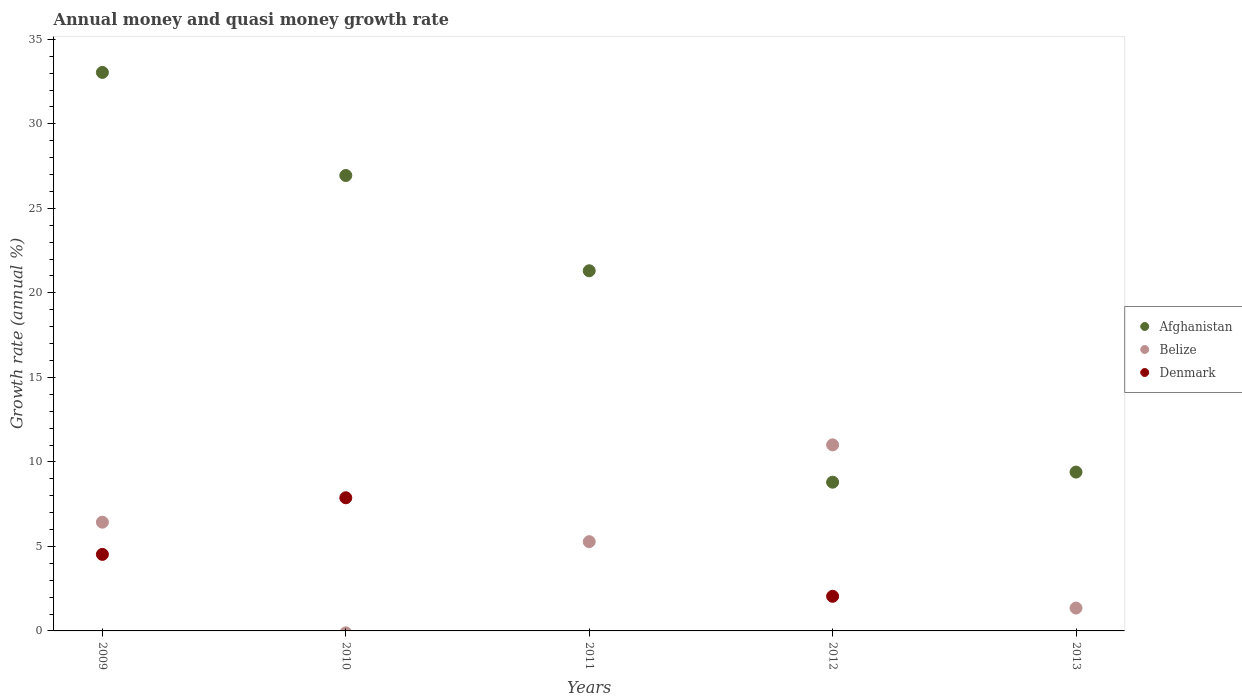What is the growth rate in Denmark in 2012?
Give a very brief answer. 2.05. Across all years, what is the maximum growth rate in Denmark?
Provide a succinct answer. 7.88. Across all years, what is the minimum growth rate in Afghanistan?
Your answer should be very brief. 8.8. What is the total growth rate in Denmark in the graph?
Provide a short and direct response. 14.46. What is the difference between the growth rate in Belize in 2012 and that in 2013?
Your response must be concise. 9.66. What is the difference between the growth rate in Denmark in 2009 and the growth rate in Afghanistan in 2010?
Your answer should be very brief. -22.42. What is the average growth rate in Belize per year?
Give a very brief answer. 4.82. In the year 2009, what is the difference between the growth rate in Belize and growth rate in Denmark?
Your response must be concise. 1.91. What is the ratio of the growth rate in Afghanistan in 2010 to that in 2011?
Offer a very short reply. 1.26. Is the growth rate in Denmark in 2009 less than that in 2012?
Give a very brief answer. No. What is the difference between the highest and the second highest growth rate in Afghanistan?
Your answer should be very brief. 6.1. What is the difference between the highest and the lowest growth rate in Afghanistan?
Provide a short and direct response. 24.24. In how many years, is the growth rate in Denmark greater than the average growth rate in Denmark taken over all years?
Keep it short and to the point. 2. Is the growth rate in Belize strictly greater than the growth rate in Afghanistan over the years?
Make the answer very short. No. How many dotlines are there?
Your answer should be compact. 3. How many years are there in the graph?
Keep it short and to the point. 5. What is the difference between two consecutive major ticks on the Y-axis?
Your answer should be compact. 5. Are the values on the major ticks of Y-axis written in scientific E-notation?
Offer a very short reply. No. Where does the legend appear in the graph?
Your answer should be compact. Center right. How many legend labels are there?
Provide a succinct answer. 3. How are the legend labels stacked?
Ensure brevity in your answer.  Vertical. What is the title of the graph?
Offer a terse response. Annual money and quasi money growth rate. Does "Hong Kong" appear as one of the legend labels in the graph?
Make the answer very short. No. What is the label or title of the X-axis?
Your answer should be compact. Years. What is the label or title of the Y-axis?
Ensure brevity in your answer.  Growth rate (annual %). What is the Growth rate (annual %) in Afghanistan in 2009?
Make the answer very short. 33.05. What is the Growth rate (annual %) in Belize in 2009?
Your answer should be very brief. 6.43. What is the Growth rate (annual %) of Denmark in 2009?
Your response must be concise. 4.53. What is the Growth rate (annual %) of Afghanistan in 2010?
Offer a very short reply. 26.95. What is the Growth rate (annual %) of Belize in 2010?
Offer a terse response. 0. What is the Growth rate (annual %) of Denmark in 2010?
Provide a succinct answer. 7.88. What is the Growth rate (annual %) in Afghanistan in 2011?
Offer a very short reply. 21.31. What is the Growth rate (annual %) of Belize in 2011?
Provide a short and direct response. 5.28. What is the Growth rate (annual %) of Denmark in 2011?
Your response must be concise. 0. What is the Growth rate (annual %) of Afghanistan in 2012?
Your answer should be very brief. 8.8. What is the Growth rate (annual %) of Belize in 2012?
Your answer should be compact. 11.01. What is the Growth rate (annual %) in Denmark in 2012?
Provide a short and direct response. 2.05. What is the Growth rate (annual %) of Afghanistan in 2013?
Offer a very short reply. 9.4. What is the Growth rate (annual %) in Belize in 2013?
Make the answer very short. 1.35. Across all years, what is the maximum Growth rate (annual %) in Afghanistan?
Your answer should be compact. 33.05. Across all years, what is the maximum Growth rate (annual %) in Belize?
Offer a very short reply. 11.01. Across all years, what is the maximum Growth rate (annual %) of Denmark?
Ensure brevity in your answer.  7.88. Across all years, what is the minimum Growth rate (annual %) in Afghanistan?
Ensure brevity in your answer.  8.8. Across all years, what is the minimum Growth rate (annual %) in Denmark?
Offer a terse response. 0. What is the total Growth rate (annual %) of Afghanistan in the graph?
Offer a very short reply. 99.5. What is the total Growth rate (annual %) in Belize in the graph?
Provide a short and direct response. 24.08. What is the total Growth rate (annual %) of Denmark in the graph?
Your answer should be compact. 14.46. What is the difference between the Growth rate (annual %) of Afghanistan in 2009 and that in 2010?
Offer a terse response. 6.1. What is the difference between the Growth rate (annual %) of Denmark in 2009 and that in 2010?
Ensure brevity in your answer.  -3.35. What is the difference between the Growth rate (annual %) in Afghanistan in 2009 and that in 2011?
Your answer should be compact. 11.74. What is the difference between the Growth rate (annual %) in Belize in 2009 and that in 2011?
Your answer should be very brief. 1.15. What is the difference between the Growth rate (annual %) of Afghanistan in 2009 and that in 2012?
Your answer should be compact. 24.25. What is the difference between the Growth rate (annual %) of Belize in 2009 and that in 2012?
Your answer should be very brief. -4.57. What is the difference between the Growth rate (annual %) in Denmark in 2009 and that in 2012?
Give a very brief answer. 2.48. What is the difference between the Growth rate (annual %) of Afghanistan in 2009 and that in 2013?
Keep it short and to the point. 23.65. What is the difference between the Growth rate (annual %) in Belize in 2009 and that in 2013?
Your response must be concise. 5.08. What is the difference between the Growth rate (annual %) in Afghanistan in 2010 and that in 2011?
Offer a very short reply. 5.64. What is the difference between the Growth rate (annual %) in Afghanistan in 2010 and that in 2012?
Keep it short and to the point. 18.15. What is the difference between the Growth rate (annual %) of Denmark in 2010 and that in 2012?
Provide a succinct answer. 5.83. What is the difference between the Growth rate (annual %) of Afghanistan in 2010 and that in 2013?
Offer a terse response. 17.55. What is the difference between the Growth rate (annual %) in Afghanistan in 2011 and that in 2012?
Give a very brief answer. 12.51. What is the difference between the Growth rate (annual %) in Belize in 2011 and that in 2012?
Your response must be concise. -5.73. What is the difference between the Growth rate (annual %) in Afghanistan in 2011 and that in 2013?
Give a very brief answer. 11.91. What is the difference between the Growth rate (annual %) of Belize in 2011 and that in 2013?
Ensure brevity in your answer.  3.93. What is the difference between the Growth rate (annual %) of Afghanistan in 2012 and that in 2013?
Your answer should be very brief. -0.6. What is the difference between the Growth rate (annual %) of Belize in 2012 and that in 2013?
Your answer should be very brief. 9.66. What is the difference between the Growth rate (annual %) in Afghanistan in 2009 and the Growth rate (annual %) in Denmark in 2010?
Your response must be concise. 25.17. What is the difference between the Growth rate (annual %) in Belize in 2009 and the Growth rate (annual %) in Denmark in 2010?
Offer a very short reply. -1.44. What is the difference between the Growth rate (annual %) in Afghanistan in 2009 and the Growth rate (annual %) in Belize in 2011?
Give a very brief answer. 27.76. What is the difference between the Growth rate (annual %) in Afghanistan in 2009 and the Growth rate (annual %) in Belize in 2012?
Provide a succinct answer. 22.04. What is the difference between the Growth rate (annual %) in Afghanistan in 2009 and the Growth rate (annual %) in Denmark in 2012?
Your answer should be very brief. 31. What is the difference between the Growth rate (annual %) of Belize in 2009 and the Growth rate (annual %) of Denmark in 2012?
Your response must be concise. 4.39. What is the difference between the Growth rate (annual %) in Afghanistan in 2009 and the Growth rate (annual %) in Belize in 2013?
Keep it short and to the point. 31.69. What is the difference between the Growth rate (annual %) in Afghanistan in 2010 and the Growth rate (annual %) in Belize in 2011?
Your response must be concise. 21.67. What is the difference between the Growth rate (annual %) of Afghanistan in 2010 and the Growth rate (annual %) of Belize in 2012?
Provide a short and direct response. 15.94. What is the difference between the Growth rate (annual %) in Afghanistan in 2010 and the Growth rate (annual %) in Denmark in 2012?
Your answer should be very brief. 24.9. What is the difference between the Growth rate (annual %) of Afghanistan in 2010 and the Growth rate (annual %) of Belize in 2013?
Make the answer very short. 25.59. What is the difference between the Growth rate (annual %) of Afghanistan in 2011 and the Growth rate (annual %) of Belize in 2012?
Give a very brief answer. 10.3. What is the difference between the Growth rate (annual %) in Afghanistan in 2011 and the Growth rate (annual %) in Denmark in 2012?
Ensure brevity in your answer.  19.26. What is the difference between the Growth rate (annual %) in Belize in 2011 and the Growth rate (annual %) in Denmark in 2012?
Offer a very short reply. 3.23. What is the difference between the Growth rate (annual %) in Afghanistan in 2011 and the Growth rate (annual %) in Belize in 2013?
Your answer should be compact. 19.96. What is the difference between the Growth rate (annual %) of Afghanistan in 2012 and the Growth rate (annual %) of Belize in 2013?
Make the answer very short. 7.45. What is the average Growth rate (annual %) in Afghanistan per year?
Offer a terse response. 19.9. What is the average Growth rate (annual %) of Belize per year?
Keep it short and to the point. 4.82. What is the average Growth rate (annual %) in Denmark per year?
Keep it short and to the point. 2.89. In the year 2009, what is the difference between the Growth rate (annual %) in Afghanistan and Growth rate (annual %) in Belize?
Offer a terse response. 26.61. In the year 2009, what is the difference between the Growth rate (annual %) in Afghanistan and Growth rate (annual %) in Denmark?
Your response must be concise. 28.52. In the year 2009, what is the difference between the Growth rate (annual %) in Belize and Growth rate (annual %) in Denmark?
Give a very brief answer. 1.91. In the year 2010, what is the difference between the Growth rate (annual %) in Afghanistan and Growth rate (annual %) in Denmark?
Give a very brief answer. 19.07. In the year 2011, what is the difference between the Growth rate (annual %) of Afghanistan and Growth rate (annual %) of Belize?
Your answer should be compact. 16.03. In the year 2012, what is the difference between the Growth rate (annual %) of Afghanistan and Growth rate (annual %) of Belize?
Make the answer very short. -2.21. In the year 2012, what is the difference between the Growth rate (annual %) in Afghanistan and Growth rate (annual %) in Denmark?
Offer a terse response. 6.75. In the year 2012, what is the difference between the Growth rate (annual %) of Belize and Growth rate (annual %) of Denmark?
Keep it short and to the point. 8.96. In the year 2013, what is the difference between the Growth rate (annual %) in Afghanistan and Growth rate (annual %) in Belize?
Provide a succinct answer. 8.04. What is the ratio of the Growth rate (annual %) of Afghanistan in 2009 to that in 2010?
Give a very brief answer. 1.23. What is the ratio of the Growth rate (annual %) in Denmark in 2009 to that in 2010?
Provide a succinct answer. 0.57. What is the ratio of the Growth rate (annual %) of Afghanistan in 2009 to that in 2011?
Your answer should be very brief. 1.55. What is the ratio of the Growth rate (annual %) in Belize in 2009 to that in 2011?
Provide a short and direct response. 1.22. What is the ratio of the Growth rate (annual %) of Afghanistan in 2009 to that in 2012?
Offer a very short reply. 3.76. What is the ratio of the Growth rate (annual %) in Belize in 2009 to that in 2012?
Provide a succinct answer. 0.58. What is the ratio of the Growth rate (annual %) in Denmark in 2009 to that in 2012?
Your answer should be compact. 2.21. What is the ratio of the Growth rate (annual %) in Afghanistan in 2009 to that in 2013?
Give a very brief answer. 3.52. What is the ratio of the Growth rate (annual %) in Belize in 2009 to that in 2013?
Your answer should be very brief. 4.76. What is the ratio of the Growth rate (annual %) in Afghanistan in 2010 to that in 2011?
Offer a very short reply. 1.26. What is the ratio of the Growth rate (annual %) of Afghanistan in 2010 to that in 2012?
Give a very brief answer. 3.06. What is the ratio of the Growth rate (annual %) in Denmark in 2010 to that in 2012?
Your answer should be compact. 3.85. What is the ratio of the Growth rate (annual %) in Afghanistan in 2010 to that in 2013?
Offer a terse response. 2.87. What is the ratio of the Growth rate (annual %) in Afghanistan in 2011 to that in 2012?
Keep it short and to the point. 2.42. What is the ratio of the Growth rate (annual %) of Belize in 2011 to that in 2012?
Your answer should be compact. 0.48. What is the ratio of the Growth rate (annual %) of Afghanistan in 2011 to that in 2013?
Give a very brief answer. 2.27. What is the ratio of the Growth rate (annual %) of Belize in 2011 to that in 2013?
Ensure brevity in your answer.  3.9. What is the ratio of the Growth rate (annual %) of Afghanistan in 2012 to that in 2013?
Provide a succinct answer. 0.94. What is the ratio of the Growth rate (annual %) of Belize in 2012 to that in 2013?
Make the answer very short. 8.14. What is the difference between the highest and the second highest Growth rate (annual %) of Afghanistan?
Your response must be concise. 6.1. What is the difference between the highest and the second highest Growth rate (annual %) of Belize?
Provide a succinct answer. 4.57. What is the difference between the highest and the second highest Growth rate (annual %) of Denmark?
Offer a terse response. 3.35. What is the difference between the highest and the lowest Growth rate (annual %) in Afghanistan?
Give a very brief answer. 24.25. What is the difference between the highest and the lowest Growth rate (annual %) in Belize?
Your response must be concise. 11.01. What is the difference between the highest and the lowest Growth rate (annual %) of Denmark?
Offer a terse response. 7.88. 